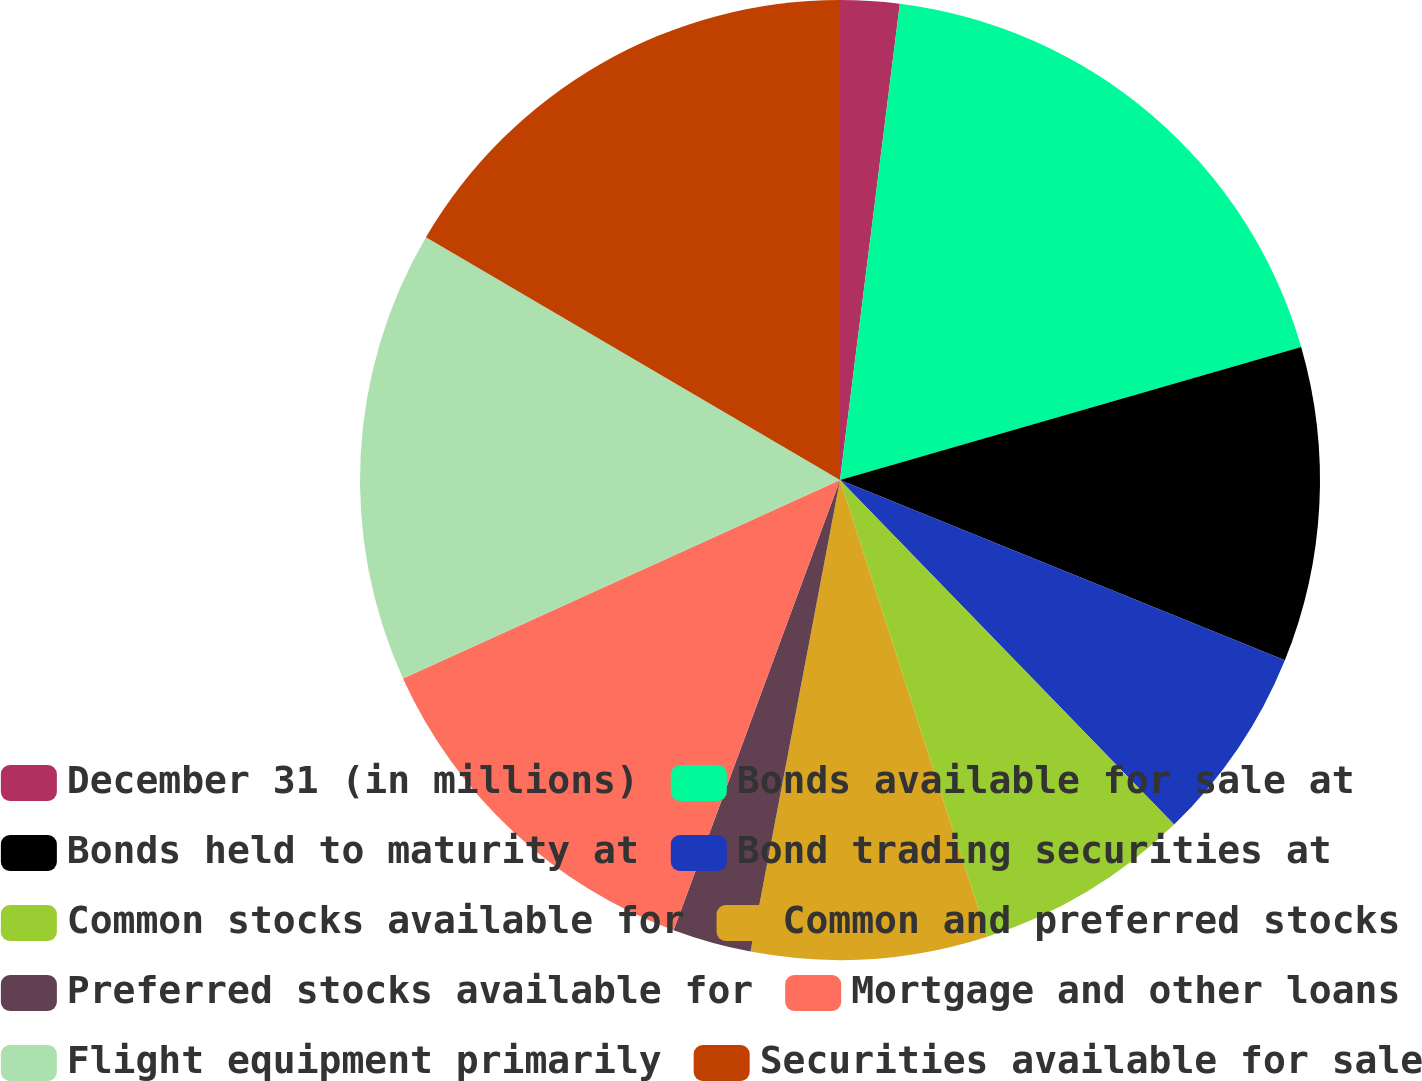Convert chart. <chart><loc_0><loc_0><loc_500><loc_500><pie_chart><fcel>December 31 (in millions)<fcel>Bonds available for sale at<fcel>Bonds held to maturity at<fcel>Bond trading securities at<fcel>Common stocks available for<fcel>Common and preferred stocks<fcel>Preferred stocks available for<fcel>Mortgage and other loans<fcel>Flight equipment primarily<fcel>Securities available for sale<nl><fcel>1.99%<fcel>18.54%<fcel>10.6%<fcel>6.62%<fcel>7.29%<fcel>7.95%<fcel>2.65%<fcel>12.58%<fcel>15.23%<fcel>16.56%<nl></chart> 